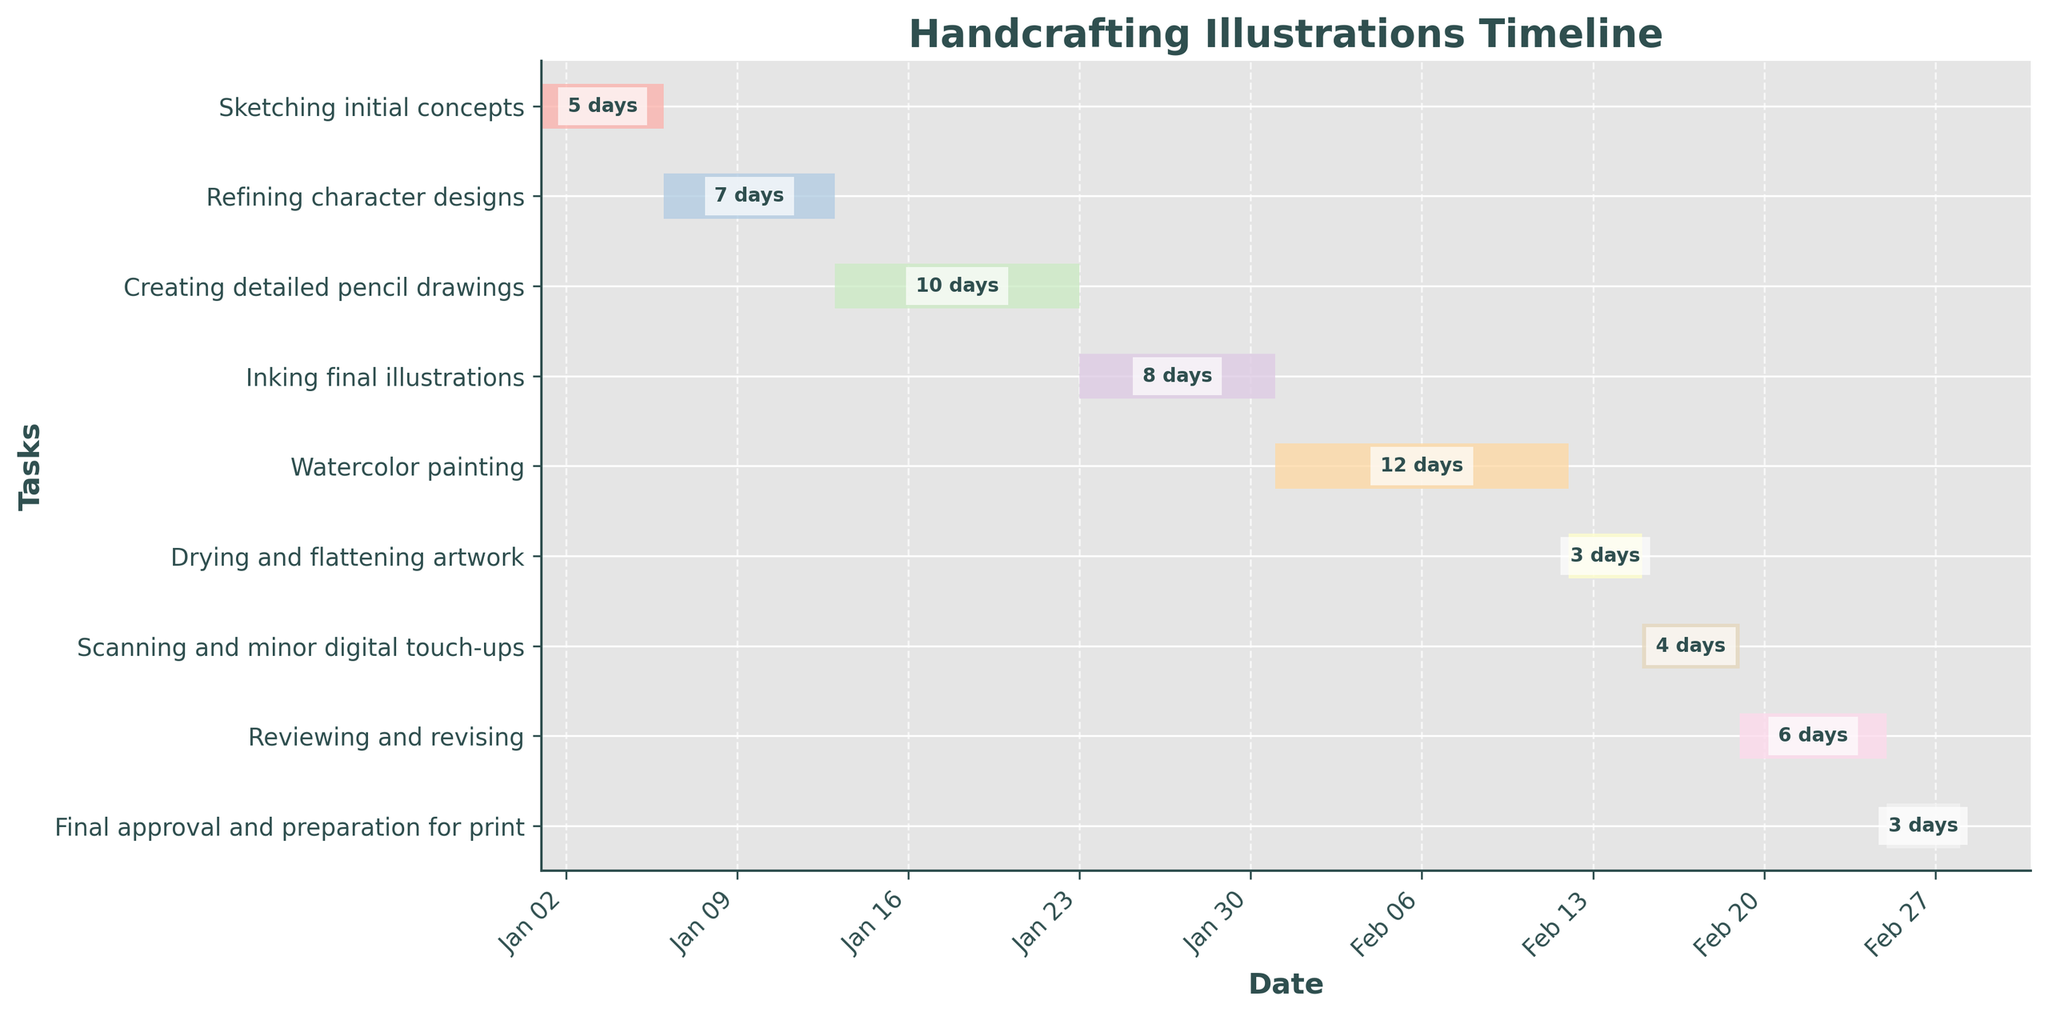What's the title of the chart? The title is written at the top of the chart.
Answer: Handcrafting Illustrations Timeline What is the date range for the "Inking final illustrations" task? To find the date range, identify the starting and ending dates of this task on the timeline.
Answer: Jan 23 - Jan 30 Which task has the longest duration? Check the number of days marked for each task and find the one with the highest value.
Answer: Watercolor painting How long does drying and flattening the artwork take? Locate the "Drying and flattening artwork" task on the timeline and read the duration label.
Answer: 3 days When does the "Refining character designs" task start? Find "Refining character designs" on the vertical list and note its starting point on the date axis.
Answer: Jan 6 Which task ends first, "Sketching initial concepts" or "Drying and flattening artwork"? Compare the ending dates of "Sketching initial concepts" and "Drying and flattening artwork" tasks.
Answer: Sketching initial concepts What tasks are performed between Jan 23 to Feb 4? Identify the tasks whose date ranges overlap with Jan 23 to Feb 4 interval.
Answer: Creating detailed pencil drawings, Inking final illustrations What is the combined duration of "Scanning and minor digital touch-ups" and "Reviewing and revising"? Sum the durations of "Scanning and minor digital touch-ups" and "Reviewing and revising" tasks.
Answer: 10 days Are there any tasks that take exactly one week? Check each task's duration to find any that last exactly 7 days.
Answer: Yes, Refining character designs Which has a later start date, "Watercolor painting" or "Final approval and preparation for print"? Compare the starting dates of "Watercolor painting" and "Final approval and preparation for print."
Answer: Final approval and preparation for print 